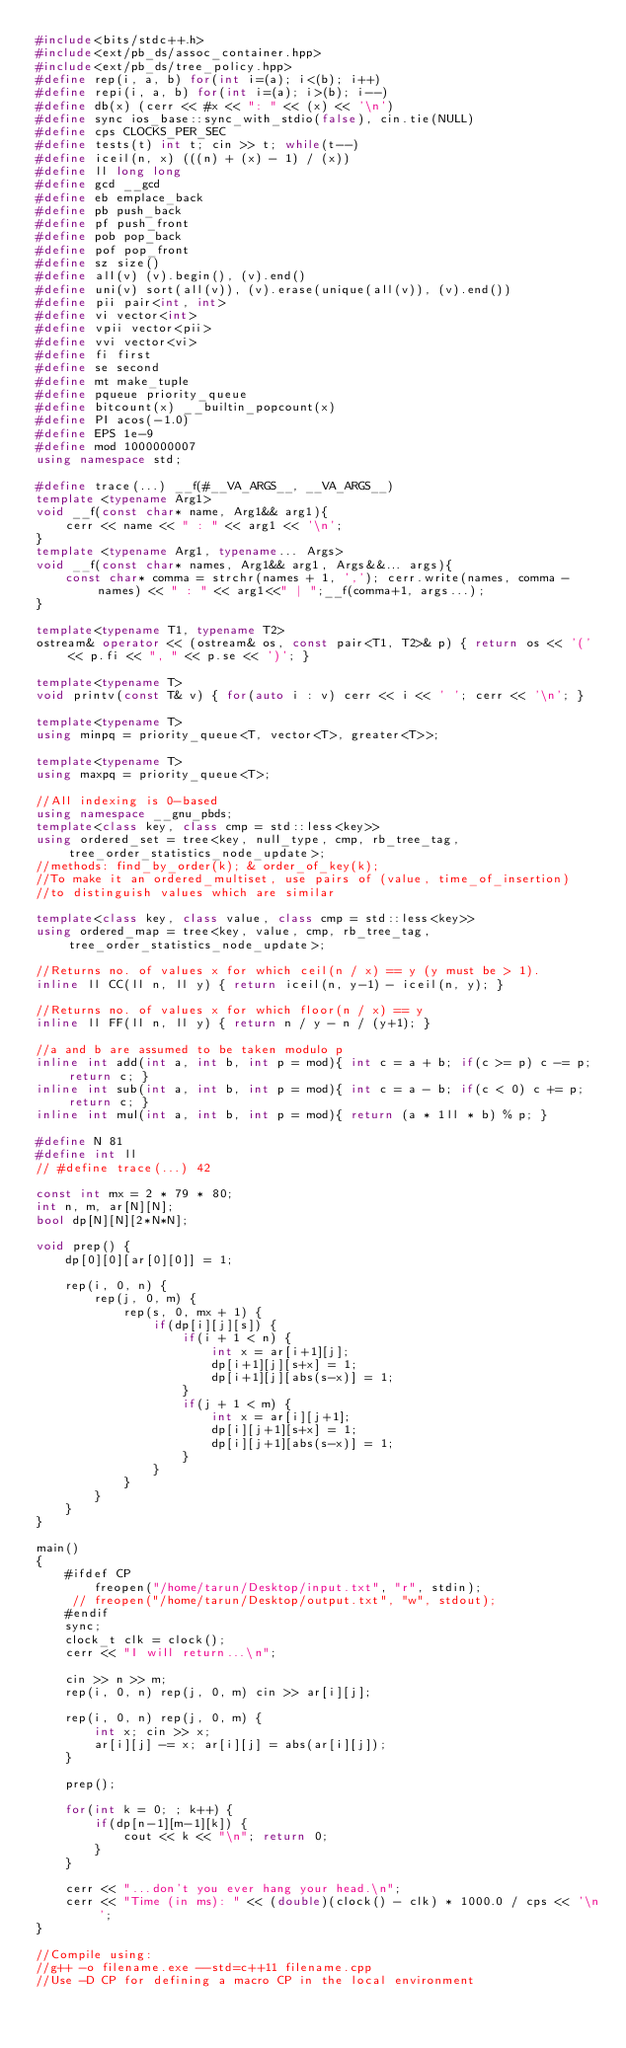Convert code to text. <code><loc_0><loc_0><loc_500><loc_500><_C++_>#include<bits/stdc++.h>
#include<ext/pb_ds/assoc_container.hpp>
#include<ext/pb_ds/tree_policy.hpp>
#define rep(i, a, b) for(int i=(a); i<(b); i++)
#define repi(i, a, b) for(int i=(a); i>(b); i--)
#define db(x) (cerr << #x << ": " << (x) << '\n')
#define sync ios_base::sync_with_stdio(false), cin.tie(NULL)
#define cps CLOCKS_PER_SEC
#define tests(t) int t; cin >> t; while(t--)
#define iceil(n, x) (((n) + (x) - 1) / (x))
#define ll long long
#define gcd __gcd
#define eb emplace_back
#define pb push_back
#define pf push_front
#define pob pop_back
#define pof pop_front
#define sz size()
#define all(v) (v).begin(), (v).end()
#define uni(v) sort(all(v)), (v).erase(unique(all(v)), (v).end())
#define pii pair<int, int>
#define vi vector<int>
#define vpii vector<pii>
#define vvi vector<vi>
#define fi first
#define se second
#define mt make_tuple
#define pqueue priority_queue
#define bitcount(x) __builtin_popcount(x)
#define PI acos(-1.0)
#define EPS 1e-9
#define mod 1000000007
using namespace std;

#define trace(...) __f(#__VA_ARGS__, __VA_ARGS__)
template <typename Arg1>
void __f(const char* name, Arg1&& arg1){
    cerr << name << " : " << arg1 << '\n';
}
template <typename Arg1, typename... Args>
void __f(const char* names, Arg1&& arg1, Args&&... args){
    const char* comma = strchr(names + 1, ','); cerr.write(names, comma - names) << " : " << arg1<<" | ";__f(comma+1, args...);
}

template<typename T1, typename T2>
ostream& operator << (ostream& os, const pair<T1, T2>& p) { return os << '(' << p.fi << ", " << p.se << ')'; }

template<typename T>
void printv(const T& v) { for(auto i : v) cerr << i << ' '; cerr << '\n'; }

template<typename T>
using minpq = priority_queue<T, vector<T>, greater<T>>;

template<typename T>
using maxpq = priority_queue<T>;

//All indexing is 0-based
using namespace __gnu_pbds;
template<class key, class cmp = std::less<key>>
using ordered_set = tree<key, null_type, cmp, rb_tree_tag, tree_order_statistics_node_update>;
//methods: find_by_order(k); & order_of_key(k);
//To make it an ordered_multiset, use pairs of (value, time_of_insertion)
//to distinguish values which are similar

template<class key, class value, class cmp = std::less<key>>
using ordered_map = tree<key, value, cmp, rb_tree_tag, tree_order_statistics_node_update>;

//Returns no. of values x for which ceil(n / x) == y (y must be > 1).
inline ll CC(ll n, ll y) { return iceil(n, y-1) - iceil(n, y); }

//Returns no. of values x for which floor(n / x) == y
inline ll FF(ll n, ll y) { return n / y - n / (y+1); }

//a and b are assumed to be taken modulo p
inline int add(int a, int b, int p = mod){ int c = a + b; if(c >= p) c -= p; return c; }
inline int sub(int a, int b, int p = mod){ int c = a - b; if(c < 0) c += p; return c; }
inline int mul(int a, int b, int p = mod){ return (a * 1ll * b) % p; }

#define N 81
#define int ll
// #define trace(...) 42

const int mx = 2 * 79 * 80;
int n, m, ar[N][N];
bool dp[N][N][2*N*N];

void prep() {
    dp[0][0][ar[0][0]] = 1;

    rep(i, 0, n) {
        rep(j, 0, m) {
            rep(s, 0, mx + 1) {
                if(dp[i][j][s]) {
                    if(i + 1 < n) {
                        int x = ar[i+1][j];
                        dp[i+1][j][s+x] = 1;
                        dp[i+1][j][abs(s-x)] = 1;
                    }
                    if(j + 1 < m) {
                        int x = ar[i][j+1];
                        dp[i][j+1][s+x] = 1;
                        dp[i][j+1][abs(s-x)] = 1;
                    }
                }
            }
        }
    }
}

main()
{   
    #ifdef CP
        freopen("/home/tarun/Desktop/input.txt", "r", stdin);
     // freopen("/home/tarun/Desktop/output.txt", "w", stdout);
    #endif
    sync;
    clock_t clk = clock();
    cerr << "I will return...\n";

    cin >> n >> m;
    rep(i, 0, n) rep(j, 0, m) cin >> ar[i][j];

    rep(i, 0, n) rep(j, 0, m) {
        int x; cin >> x;
        ar[i][j] -= x; ar[i][j] = abs(ar[i][j]);
    }

    prep();

    for(int k = 0; ; k++) {
        if(dp[n-1][m-1][k]) {
            cout << k << "\n"; return 0;
        }
    }

    cerr << "...don't you ever hang your head.\n";
    cerr << "Time (in ms): " << (double)(clock() - clk) * 1000.0 / cps << '\n';
}

//Compile using:
//g++ -o filename.exe --std=c++11 filename.cpp
//Use -D CP for defining a macro CP in the local environment


</code> 